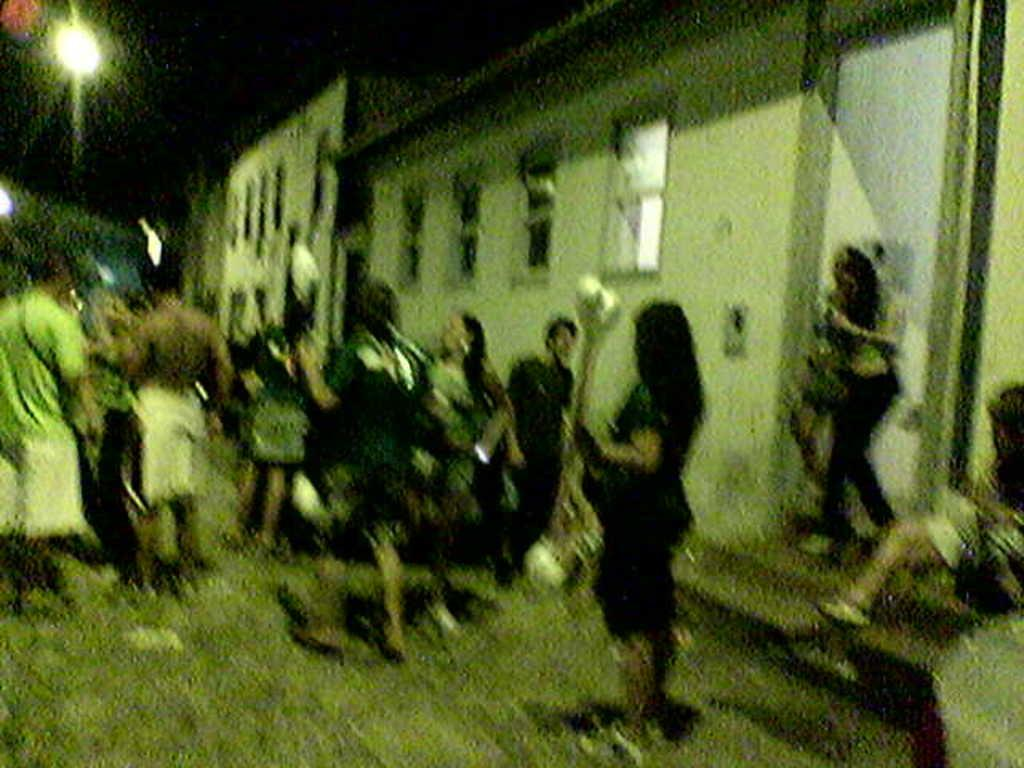Who or what is present in the image? There are people in the image. What can be seen on the left side of the image? There are buildings on the left side of the image. How can one access the building in the image? There are stairs leading to the building in the image. What is at the top of the building in the image? There is a light at the top of the building in the image. What type of stick is being used by the people in the image? There is no stick present in the image. How many cannons are visible in the image? There are no cannons present in the image. 